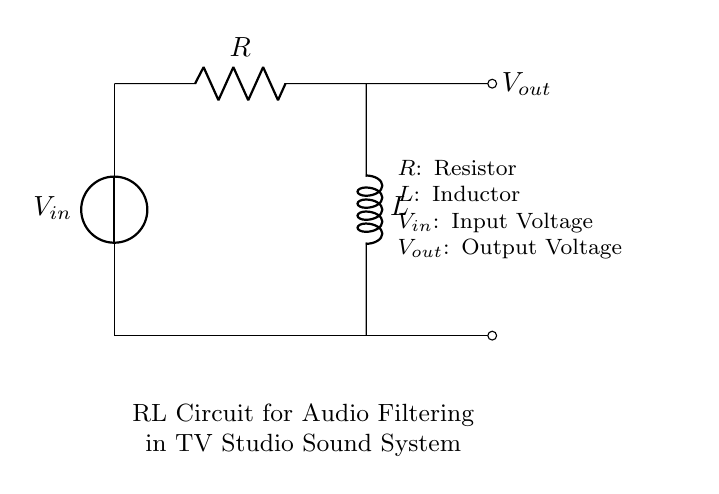What is the input voltage of the circuit? The input voltage, noted as \( V_{in} \), is indicated at the voltage source on the left side of the circuit diagram.
Answer: V_in What component is labeled as R? The component labeled as R in the circuit diagram is a resistor, which is the first component encountered when moving from the input voltage towards the output voltage.
Answer: Resistor What is the role of the inductor in this circuit? The inductor, labeled L, in this RL circuit is used for audio filtering, which typically helps in attenuating high-frequency signals and allowing lower frequencies to pass through.
Answer: Filtering How does the output voltage relate to the input voltage? The output voltage, indicated as \( V_{out} \), is taken across the inductor, which implies that it will be lower than the input voltage due to the impedance introduced by the resistor and inductor combination.
Answer: Lower What happens to the current in the circuit at high frequencies? At high frequencies, the inductor's reactance increases, leading to reduced current flow, thereby attenuating those frequencies in the output.
Answer: Reduced What is the primary purpose of this RL circuit configuration? The primary purpose of this RL circuit configuration is to filter audio signals, specifically to improve the sound quality in a TV studio sound system by reducing unwanted high-frequency noise.
Answer: Audio filtering 